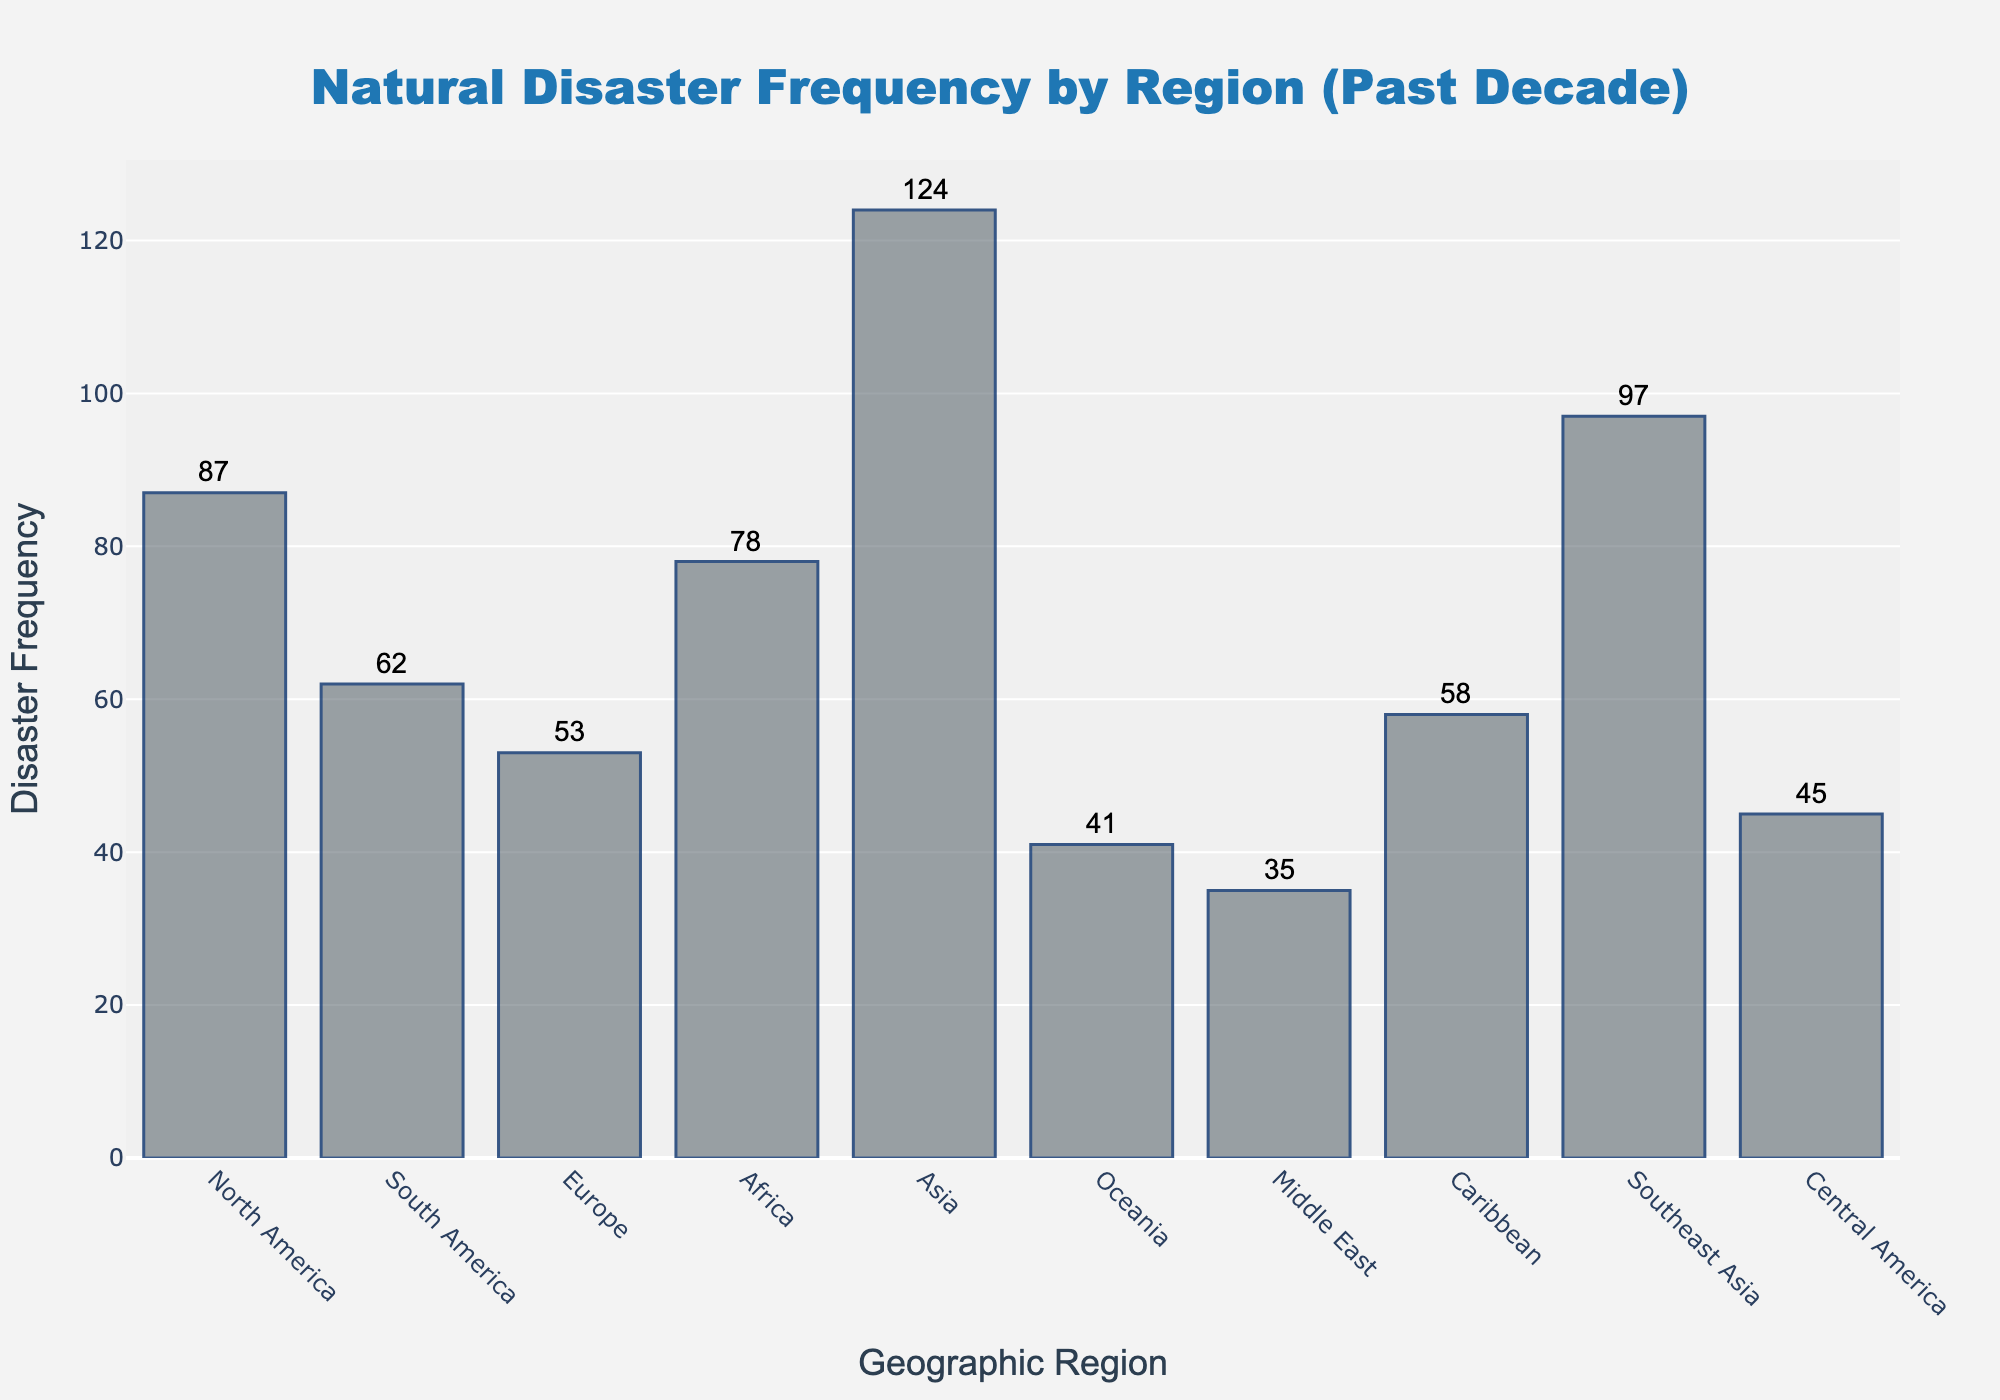what is the title of the figure? The title is displayed at the top center of the figure and reads "Natural Disaster Frequency by Region (Past Decade)".
Answer: Natural Disaster Frequency by Region (Past Decade) How many regions are included in the figure? Count each unique bar representing a geographic region. There are 10 regions included in the figure.
Answer: 10 Which region experienced the highest frequency of natural disasters? Identify the tallest bar in the histogram, which corresponds to Asia with 124 occurrences.
Answer: Asia What is the frequency of natural disasters in the Caribbean region? Look at the bar labeled "Caribbean" and read the frequency value above the bar, which is 58.
Answer: 58 What is the average frequency of natural disasters across all regions? Sum the frequencies of all regions (87+62+53+78+124+41+35+58+97+45) and divide by the number of regions (10). The sum is 680, so the average is 680/10 = 68.
Answer: 68 Which region experienced fewer disasters, Oceania or the Middle East? Compare the heights of the bars for Oceania and Middle East; Oceania has 41 and Middle East has 35, so Middle East experienced fewer disasters.
Answer: Middle East What is the difference in the frequency of natural disasters between North America and South America? Subtract the frequency of South America from the frequency of North America; 87 - 62 = 25.
Answer: 25 Which region experienced the second highest frequency of natural disasters? Identify the region with the second tallest bar; Southeast Asia with 97 occurrences is the second highest after Asia.
Answer: Southeast Asia Is the frequency of natural disasters in Europe closer to that in South America or Central America? Compare the differences: Europe (53) differs from South America (62) by 9, and from Central America (45) by 8. It's closer to Central America.
Answer: Central America What is the combined frequency of natural disasters for Africa, Asia, and Southeast Asia? Sum the frequencies of Africa, Asia, and Southeast Asia; 78 + 124 + 97 = 299.
Answer: 299 